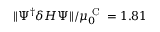Convert formula to latex. <formula><loc_0><loc_0><loc_500><loc_500>\| \Psi ^ { \dagger } \delta H \Psi \| / \mu _ { 0 } ^ { C } = 1 . 8 1</formula> 